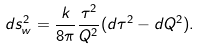<formula> <loc_0><loc_0><loc_500><loc_500>d s _ { w } ^ { 2 } = \frac { k } { 8 \pi } \frac { \tau ^ { 2 } } { Q ^ { 2 } } ( d \tau ^ { 2 } - d Q ^ { 2 } ) .</formula> 